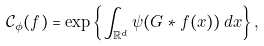<formula> <loc_0><loc_0><loc_500><loc_500>\mathcal { C } _ { \phi } ( f ) = \exp \left \{ \int _ { \mathbb { R } ^ { d } } \psi ( G * f ( x ) ) \, d x \right \} ,</formula> 